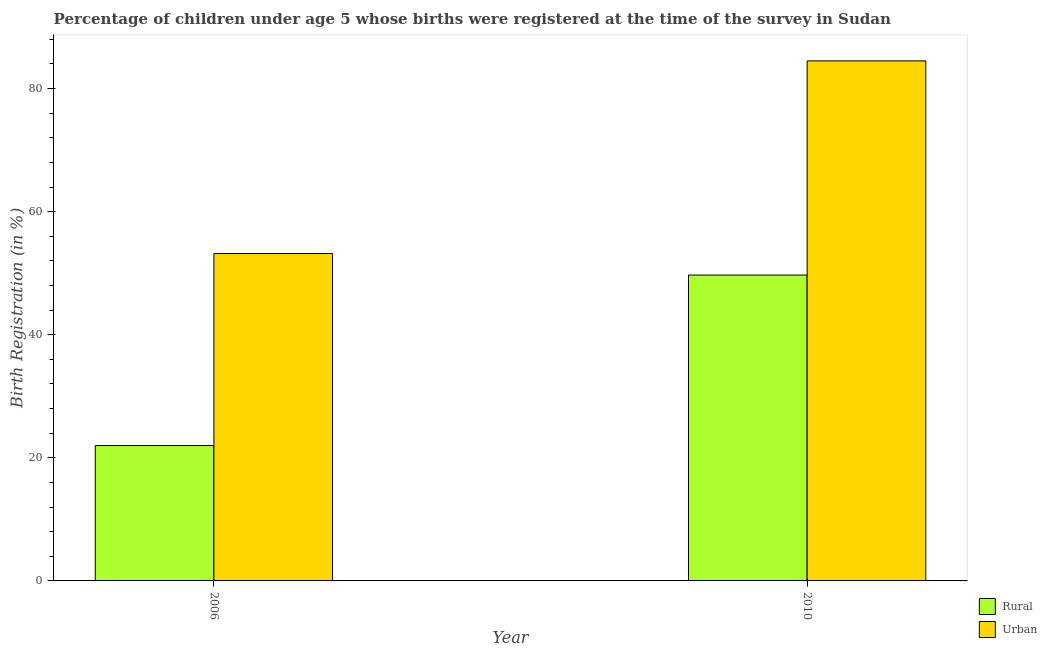How many groups of bars are there?
Offer a very short reply. 2. Are the number of bars per tick equal to the number of legend labels?
Make the answer very short. Yes. What is the urban birth registration in 2010?
Give a very brief answer. 84.5. Across all years, what is the maximum urban birth registration?
Your answer should be compact. 84.5. Across all years, what is the minimum urban birth registration?
Make the answer very short. 53.2. In which year was the urban birth registration minimum?
Your answer should be very brief. 2006. What is the total rural birth registration in the graph?
Keep it short and to the point. 71.7. What is the difference between the rural birth registration in 2006 and that in 2010?
Offer a very short reply. -27.7. What is the difference between the rural birth registration in 2006 and the urban birth registration in 2010?
Make the answer very short. -27.7. What is the average rural birth registration per year?
Make the answer very short. 35.85. In the year 2010, what is the difference between the rural birth registration and urban birth registration?
Ensure brevity in your answer.  0. What is the ratio of the urban birth registration in 2006 to that in 2010?
Ensure brevity in your answer.  0.63. Is the urban birth registration in 2006 less than that in 2010?
Provide a succinct answer. Yes. In how many years, is the urban birth registration greater than the average urban birth registration taken over all years?
Offer a very short reply. 1. What does the 2nd bar from the left in 2006 represents?
Your answer should be very brief. Urban. What does the 2nd bar from the right in 2010 represents?
Make the answer very short. Rural. Are all the bars in the graph horizontal?
Keep it short and to the point. No. How many years are there in the graph?
Offer a very short reply. 2. What is the difference between two consecutive major ticks on the Y-axis?
Provide a short and direct response. 20. Are the values on the major ticks of Y-axis written in scientific E-notation?
Keep it short and to the point. No. Does the graph contain any zero values?
Your answer should be compact. No. Does the graph contain grids?
Provide a succinct answer. No. How many legend labels are there?
Your answer should be very brief. 2. What is the title of the graph?
Ensure brevity in your answer.  Percentage of children under age 5 whose births were registered at the time of the survey in Sudan. Does "National Tourists" appear as one of the legend labels in the graph?
Provide a short and direct response. No. What is the label or title of the X-axis?
Your answer should be compact. Year. What is the label or title of the Y-axis?
Make the answer very short. Birth Registration (in %). What is the Birth Registration (in %) of Rural in 2006?
Your answer should be compact. 22. What is the Birth Registration (in %) of Urban in 2006?
Keep it short and to the point. 53.2. What is the Birth Registration (in %) in Rural in 2010?
Your response must be concise. 49.7. What is the Birth Registration (in %) in Urban in 2010?
Give a very brief answer. 84.5. Across all years, what is the maximum Birth Registration (in %) in Rural?
Keep it short and to the point. 49.7. Across all years, what is the maximum Birth Registration (in %) of Urban?
Ensure brevity in your answer.  84.5. Across all years, what is the minimum Birth Registration (in %) in Urban?
Keep it short and to the point. 53.2. What is the total Birth Registration (in %) of Rural in the graph?
Make the answer very short. 71.7. What is the total Birth Registration (in %) in Urban in the graph?
Provide a short and direct response. 137.7. What is the difference between the Birth Registration (in %) in Rural in 2006 and that in 2010?
Make the answer very short. -27.7. What is the difference between the Birth Registration (in %) of Urban in 2006 and that in 2010?
Provide a succinct answer. -31.3. What is the difference between the Birth Registration (in %) of Rural in 2006 and the Birth Registration (in %) of Urban in 2010?
Provide a short and direct response. -62.5. What is the average Birth Registration (in %) in Rural per year?
Give a very brief answer. 35.85. What is the average Birth Registration (in %) of Urban per year?
Offer a terse response. 68.85. In the year 2006, what is the difference between the Birth Registration (in %) of Rural and Birth Registration (in %) of Urban?
Provide a short and direct response. -31.2. In the year 2010, what is the difference between the Birth Registration (in %) of Rural and Birth Registration (in %) of Urban?
Your answer should be compact. -34.8. What is the ratio of the Birth Registration (in %) of Rural in 2006 to that in 2010?
Make the answer very short. 0.44. What is the ratio of the Birth Registration (in %) of Urban in 2006 to that in 2010?
Your response must be concise. 0.63. What is the difference between the highest and the second highest Birth Registration (in %) in Rural?
Your response must be concise. 27.7. What is the difference between the highest and the second highest Birth Registration (in %) of Urban?
Give a very brief answer. 31.3. What is the difference between the highest and the lowest Birth Registration (in %) in Rural?
Provide a succinct answer. 27.7. What is the difference between the highest and the lowest Birth Registration (in %) in Urban?
Your response must be concise. 31.3. 